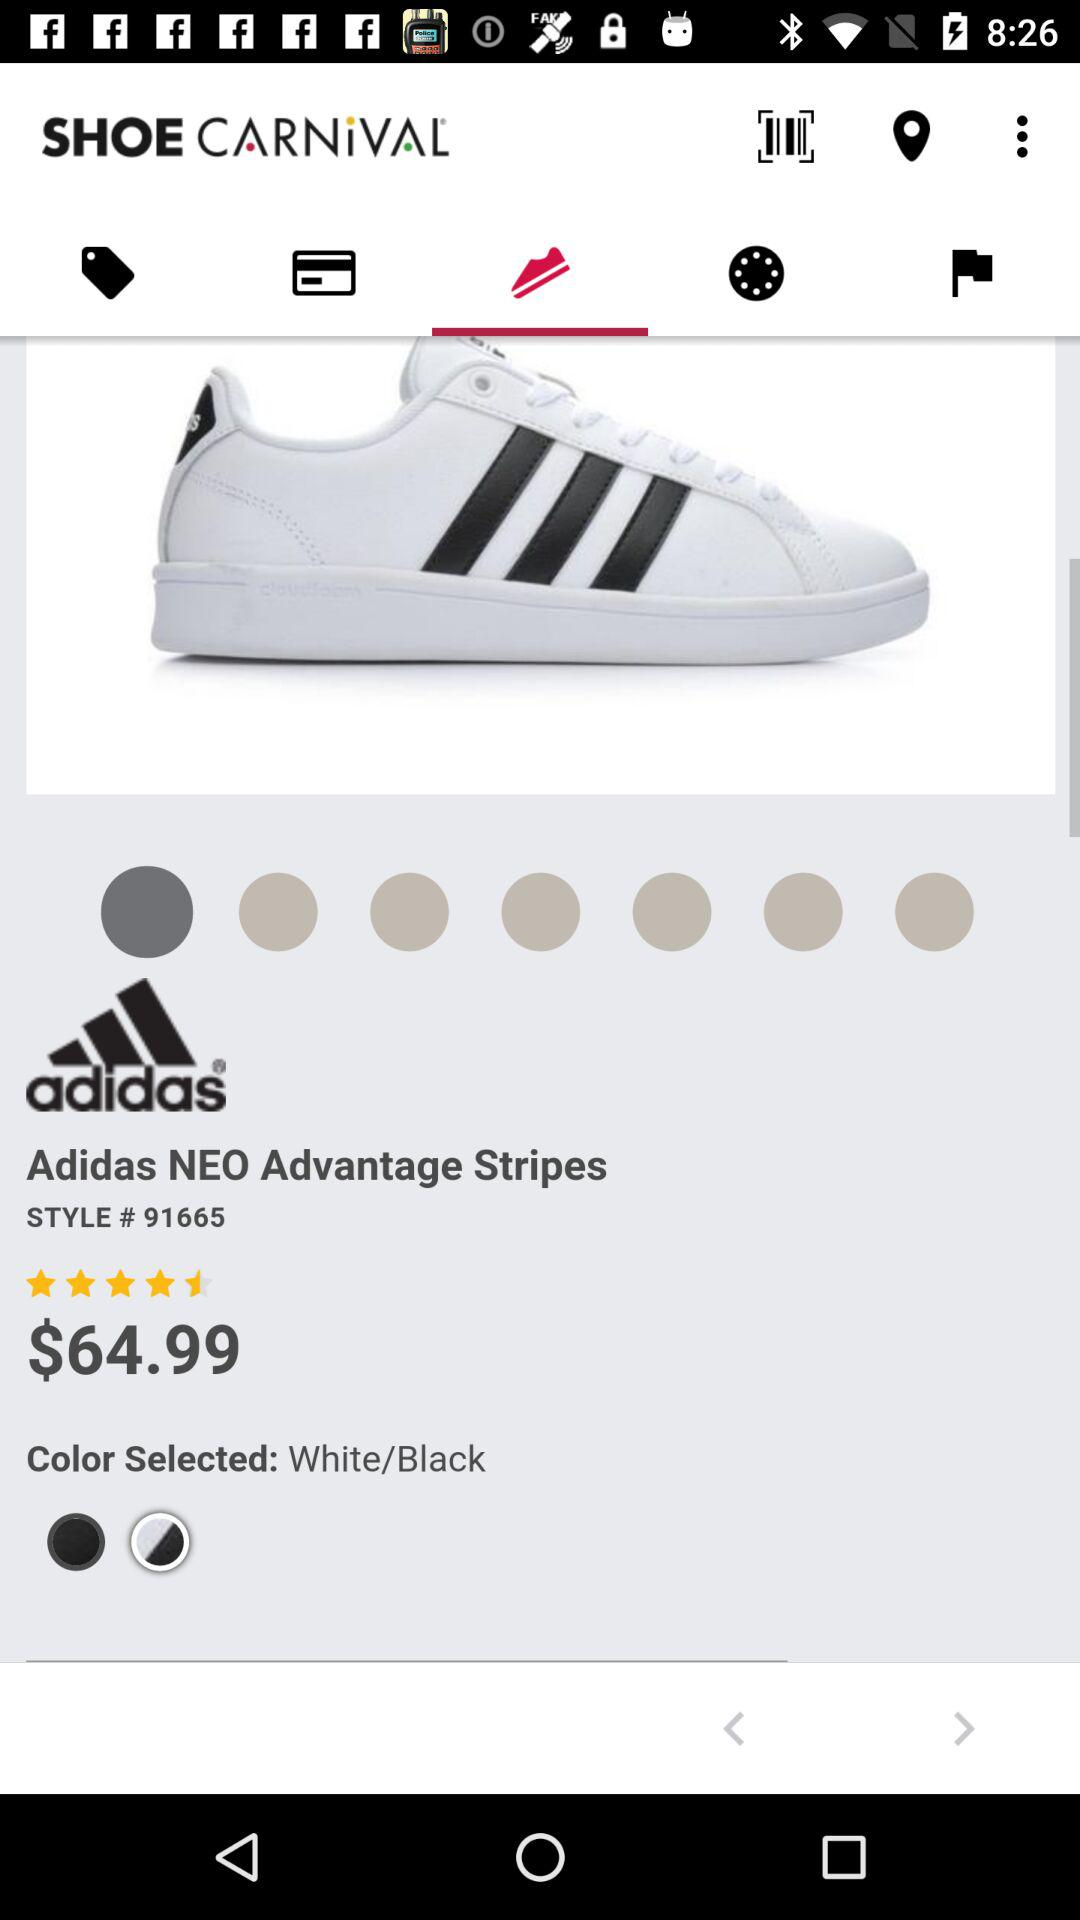What is the application name? The application name is "SHOE CARNiVAL". 